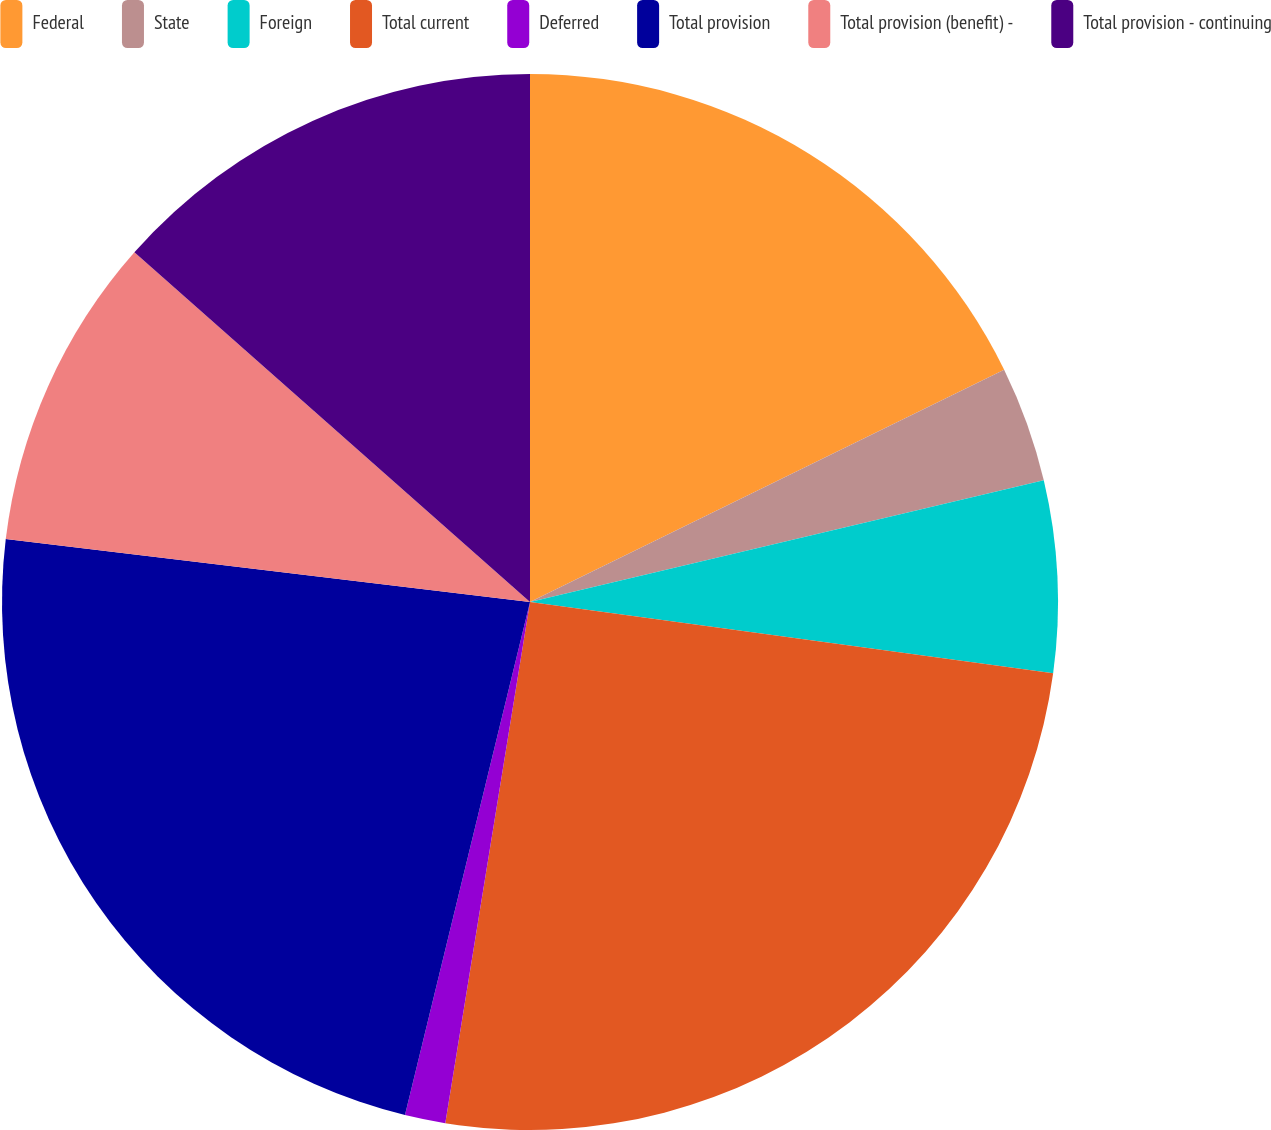Convert chart to OTSL. <chart><loc_0><loc_0><loc_500><loc_500><pie_chart><fcel>Federal<fcel>State<fcel>Foreign<fcel>Total current<fcel>Deferred<fcel>Total provision<fcel>Total provision (benefit) -<fcel>Total provision - continuing<nl><fcel>17.75%<fcel>3.55%<fcel>5.86%<fcel>25.41%<fcel>1.24%<fcel>23.1%<fcel>9.62%<fcel>13.48%<nl></chart> 